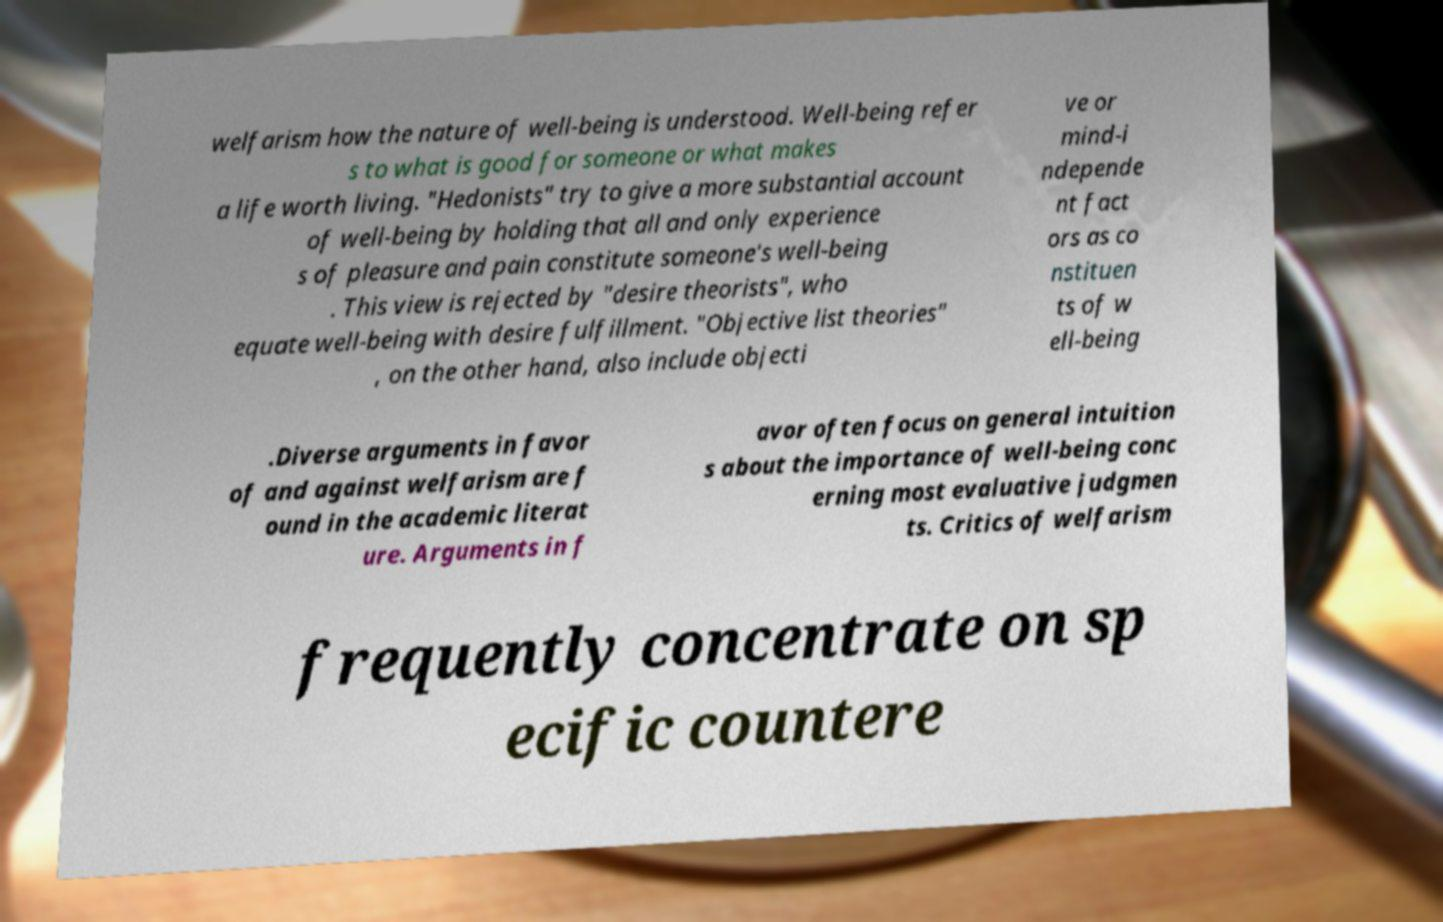Could you assist in decoding the text presented in this image and type it out clearly? welfarism how the nature of well-being is understood. Well-being refer s to what is good for someone or what makes a life worth living. "Hedonists" try to give a more substantial account of well-being by holding that all and only experience s of pleasure and pain constitute someone's well-being . This view is rejected by "desire theorists", who equate well-being with desire fulfillment. "Objective list theories" , on the other hand, also include objecti ve or mind-i ndepende nt fact ors as co nstituen ts of w ell-being .Diverse arguments in favor of and against welfarism are f ound in the academic literat ure. Arguments in f avor often focus on general intuition s about the importance of well-being conc erning most evaluative judgmen ts. Critics of welfarism frequently concentrate on sp ecific countere 